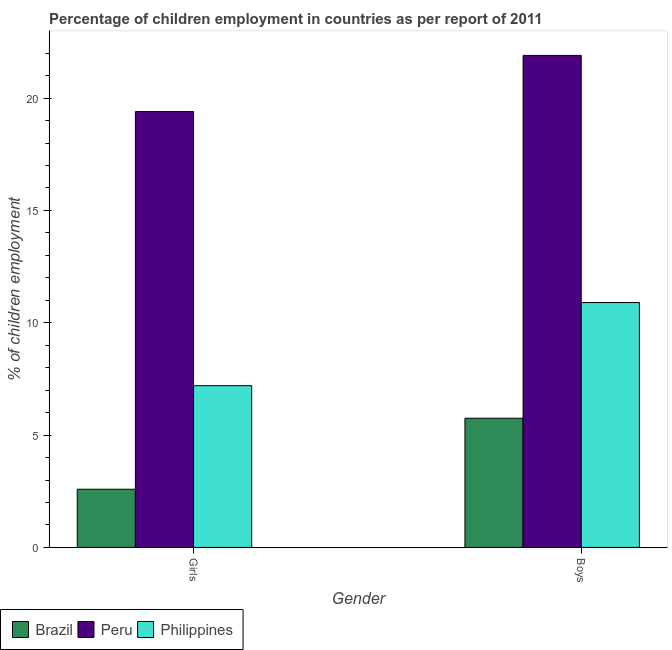How many groups of bars are there?
Give a very brief answer. 2. Are the number of bars per tick equal to the number of legend labels?
Your response must be concise. Yes. What is the label of the 2nd group of bars from the left?
Your answer should be very brief. Boys. What is the percentage of employed girls in Peru?
Your answer should be compact. 19.4. Across all countries, what is the maximum percentage of employed boys?
Provide a succinct answer. 21.9. Across all countries, what is the minimum percentage of employed boys?
Make the answer very short. 5.75. In which country was the percentage of employed girls minimum?
Give a very brief answer. Brazil. What is the total percentage of employed girls in the graph?
Keep it short and to the point. 29.19. What is the difference between the percentage of employed boys in Philippines and that in Peru?
Provide a succinct answer. -11. What is the difference between the percentage of employed boys in Brazil and the percentage of employed girls in Philippines?
Give a very brief answer. -1.45. What is the average percentage of employed boys per country?
Provide a short and direct response. 12.85. What is the difference between the percentage of employed boys and percentage of employed girls in Philippines?
Give a very brief answer. 3.7. What is the ratio of the percentage of employed boys in Peru to that in Philippines?
Your answer should be compact. 2.01. Are all the bars in the graph horizontal?
Offer a terse response. No. How many countries are there in the graph?
Provide a succinct answer. 3. What is the difference between two consecutive major ticks on the Y-axis?
Your answer should be compact. 5. Where does the legend appear in the graph?
Give a very brief answer. Bottom left. How many legend labels are there?
Offer a terse response. 3. What is the title of the graph?
Give a very brief answer. Percentage of children employment in countries as per report of 2011. Does "Macao" appear as one of the legend labels in the graph?
Provide a short and direct response. No. What is the label or title of the X-axis?
Your answer should be compact. Gender. What is the label or title of the Y-axis?
Ensure brevity in your answer.  % of children employment. What is the % of children employment of Brazil in Girls?
Keep it short and to the point. 2.59. What is the % of children employment in Brazil in Boys?
Offer a very short reply. 5.75. What is the % of children employment in Peru in Boys?
Your answer should be very brief. 21.9. Across all Gender, what is the maximum % of children employment of Brazil?
Your answer should be very brief. 5.75. Across all Gender, what is the maximum % of children employment of Peru?
Offer a terse response. 21.9. Across all Gender, what is the minimum % of children employment in Brazil?
Make the answer very short. 2.59. Across all Gender, what is the minimum % of children employment in Philippines?
Give a very brief answer. 7.2. What is the total % of children employment of Brazil in the graph?
Provide a succinct answer. 8.34. What is the total % of children employment of Peru in the graph?
Keep it short and to the point. 41.3. What is the difference between the % of children employment of Brazil in Girls and that in Boys?
Provide a short and direct response. -3.16. What is the difference between the % of children employment of Philippines in Girls and that in Boys?
Your answer should be very brief. -3.7. What is the difference between the % of children employment of Brazil in Girls and the % of children employment of Peru in Boys?
Provide a succinct answer. -19.31. What is the difference between the % of children employment of Brazil in Girls and the % of children employment of Philippines in Boys?
Ensure brevity in your answer.  -8.31. What is the difference between the % of children employment of Peru in Girls and the % of children employment of Philippines in Boys?
Your response must be concise. 8.5. What is the average % of children employment in Brazil per Gender?
Make the answer very short. 4.17. What is the average % of children employment in Peru per Gender?
Give a very brief answer. 20.65. What is the average % of children employment of Philippines per Gender?
Give a very brief answer. 9.05. What is the difference between the % of children employment in Brazil and % of children employment in Peru in Girls?
Make the answer very short. -16.81. What is the difference between the % of children employment in Brazil and % of children employment in Philippines in Girls?
Offer a very short reply. -4.61. What is the difference between the % of children employment in Brazil and % of children employment in Peru in Boys?
Provide a short and direct response. -16.15. What is the difference between the % of children employment in Brazil and % of children employment in Philippines in Boys?
Give a very brief answer. -5.15. What is the ratio of the % of children employment of Brazil in Girls to that in Boys?
Keep it short and to the point. 0.45. What is the ratio of the % of children employment of Peru in Girls to that in Boys?
Give a very brief answer. 0.89. What is the ratio of the % of children employment of Philippines in Girls to that in Boys?
Your answer should be compact. 0.66. What is the difference between the highest and the second highest % of children employment in Brazil?
Offer a very short reply. 3.16. What is the difference between the highest and the second highest % of children employment in Philippines?
Give a very brief answer. 3.7. What is the difference between the highest and the lowest % of children employment in Brazil?
Your response must be concise. 3.16. 